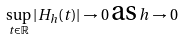Convert formula to latex. <formula><loc_0><loc_0><loc_500><loc_500>\sup _ { t \in \mathbb { R } } | H _ { h } ( t ) | \rightarrow 0 \, \text {as} \, h \rightarrow 0</formula> 